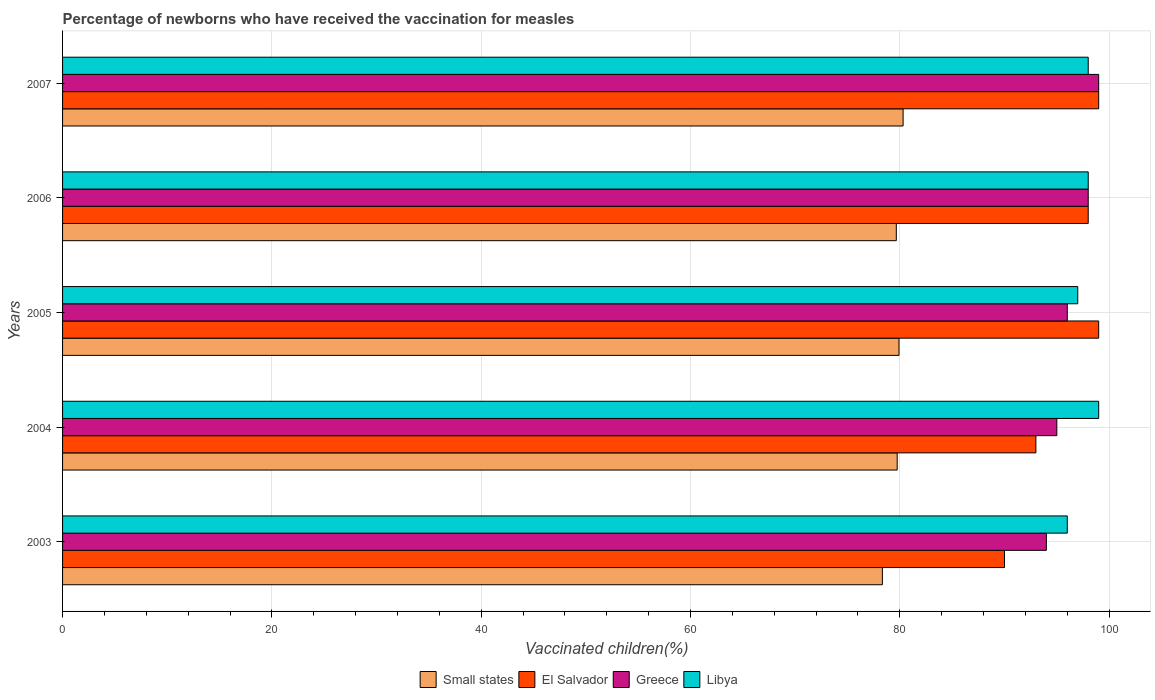Are the number of bars per tick equal to the number of legend labels?
Keep it short and to the point. Yes. How many bars are there on the 4th tick from the top?
Ensure brevity in your answer.  4. Across all years, what is the maximum percentage of vaccinated children in Greece?
Make the answer very short. 99. Across all years, what is the minimum percentage of vaccinated children in El Salvador?
Your answer should be compact. 90. In which year was the percentage of vaccinated children in Greece maximum?
Provide a short and direct response. 2007. In which year was the percentage of vaccinated children in Libya minimum?
Offer a very short reply. 2003. What is the total percentage of vaccinated children in El Salvador in the graph?
Your response must be concise. 479. What is the difference between the percentage of vaccinated children in Greece in 2003 and that in 2007?
Provide a succinct answer. -5. What is the average percentage of vaccinated children in El Salvador per year?
Your answer should be very brief. 95.8. In the year 2007, what is the difference between the percentage of vaccinated children in Libya and percentage of vaccinated children in Small states?
Offer a terse response. 17.69. In how many years, is the percentage of vaccinated children in Libya greater than 12 %?
Ensure brevity in your answer.  5. What is the ratio of the percentage of vaccinated children in El Salvador in 2004 to that in 2006?
Provide a succinct answer. 0.95. Is the percentage of vaccinated children in Libya in 2004 less than that in 2007?
Keep it short and to the point. No. What is the difference between the highest and the second highest percentage of vaccinated children in Small states?
Provide a short and direct response. 0.39. What is the difference between the highest and the lowest percentage of vaccinated children in Libya?
Offer a very short reply. 3. In how many years, is the percentage of vaccinated children in Libya greater than the average percentage of vaccinated children in Libya taken over all years?
Give a very brief answer. 3. Is it the case that in every year, the sum of the percentage of vaccinated children in Greece and percentage of vaccinated children in Libya is greater than the sum of percentage of vaccinated children in Small states and percentage of vaccinated children in El Salvador?
Give a very brief answer. Yes. What does the 1st bar from the top in 2004 represents?
Your answer should be compact. Libya. Are all the bars in the graph horizontal?
Your response must be concise. Yes. What is the difference between two consecutive major ticks on the X-axis?
Offer a very short reply. 20. Does the graph contain any zero values?
Keep it short and to the point. No. Where does the legend appear in the graph?
Make the answer very short. Bottom center. How many legend labels are there?
Give a very brief answer. 4. How are the legend labels stacked?
Provide a succinct answer. Horizontal. What is the title of the graph?
Keep it short and to the point. Percentage of newborns who have received the vaccination for measles. What is the label or title of the X-axis?
Provide a succinct answer. Vaccinated children(%). What is the Vaccinated children(%) in Small states in 2003?
Provide a succinct answer. 78.33. What is the Vaccinated children(%) of Greece in 2003?
Ensure brevity in your answer.  94. What is the Vaccinated children(%) in Libya in 2003?
Your response must be concise. 96. What is the Vaccinated children(%) in Small states in 2004?
Provide a short and direct response. 79.75. What is the Vaccinated children(%) in El Salvador in 2004?
Provide a succinct answer. 93. What is the Vaccinated children(%) of Greece in 2004?
Give a very brief answer. 95. What is the Vaccinated children(%) in Small states in 2005?
Keep it short and to the point. 79.92. What is the Vaccinated children(%) of El Salvador in 2005?
Give a very brief answer. 99. What is the Vaccinated children(%) in Greece in 2005?
Ensure brevity in your answer.  96. What is the Vaccinated children(%) of Libya in 2005?
Offer a very short reply. 97. What is the Vaccinated children(%) in Small states in 2006?
Give a very brief answer. 79.66. What is the Vaccinated children(%) of El Salvador in 2006?
Your answer should be very brief. 98. What is the Vaccinated children(%) of Greece in 2006?
Offer a very short reply. 98. What is the Vaccinated children(%) of Small states in 2007?
Make the answer very short. 80.31. What is the Vaccinated children(%) in El Salvador in 2007?
Keep it short and to the point. 99. What is the Vaccinated children(%) of Greece in 2007?
Provide a short and direct response. 99. What is the Vaccinated children(%) in Libya in 2007?
Give a very brief answer. 98. Across all years, what is the maximum Vaccinated children(%) of Small states?
Give a very brief answer. 80.31. Across all years, what is the maximum Vaccinated children(%) of Greece?
Give a very brief answer. 99. Across all years, what is the minimum Vaccinated children(%) in Small states?
Provide a short and direct response. 78.33. Across all years, what is the minimum Vaccinated children(%) in El Salvador?
Your response must be concise. 90. Across all years, what is the minimum Vaccinated children(%) in Greece?
Provide a succinct answer. 94. Across all years, what is the minimum Vaccinated children(%) in Libya?
Provide a short and direct response. 96. What is the total Vaccinated children(%) in Small states in the graph?
Offer a very short reply. 397.98. What is the total Vaccinated children(%) in El Salvador in the graph?
Ensure brevity in your answer.  479. What is the total Vaccinated children(%) of Greece in the graph?
Give a very brief answer. 482. What is the total Vaccinated children(%) of Libya in the graph?
Make the answer very short. 488. What is the difference between the Vaccinated children(%) in Small states in 2003 and that in 2004?
Offer a terse response. -1.41. What is the difference between the Vaccinated children(%) of Libya in 2003 and that in 2004?
Ensure brevity in your answer.  -3. What is the difference between the Vaccinated children(%) in Small states in 2003 and that in 2005?
Offer a terse response. -1.59. What is the difference between the Vaccinated children(%) in El Salvador in 2003 and that in 2005?
Ensure brevity in your answer.  -9. What is the difference between the Vaccinated children(%) in Small states in 2003 and that in 2006?
Your answer should be compact. -1.33. What is the difference between the Vaccinated children(%) in Greece in 2003 and that in 2006?
Ensure brevity in your answer.  -4. What is the difference between the Vaccinated children(%) in Libya in 2003 and that in 2006?
Make the answer very short. -2. What is the difference between the Vaccinated children(%) in Small states in 2003 and that in 2007?
Offer a very short reply. -1.98. What is the difference between the Vaccinated children(%) of El Salvador in 2003 and that in 2007?
Your response must be concise. -9. What is the difference between the Vaccinated children(%) of Greece in 2003 and that in 2007?
Your answer should be very brief. -5. What is the difference between the Vaccinated children(%) of Libya in 2003 and that in 2007?
Ensure brevity in your answer.  -2. What is the difference between the Vaccinated children(%) in Small states in 2004 and that in 2005?
Make the answer very short. -0.17. What is the difference between the Vaccinated children(%) in Libya in 2004 and that in 2005?
Make the answer very short. 2. What is the difference between the Vaccinated children(%) in Small states in 2004 and that in 2006?
Offer a very short reply. 0.08. What is the difference between the Vaccinated children(%) in Libya in 2004 and that in 2006?
Make the answer very short. 1. What is the difference between the Vaccinated children(%) of Small states in 2004 and that in 2007?
Keep it short and to the point. -0.56. What is the difference between the Vaccinated children(%) of El Salvador in 2004 and that in 2007?
Offer a terse response. -6. What is the difference between the Vaccinated children(%) in Libya in 2004 and that in 2007?
Provide a short and direct response. 1. What is the difference between the Vaccinated children(%) in Small states in 2005 and that in 2006?
Offer a very short reply. 0.26. What is the difference between the Vaccinated children(%) in El Salvador in 2005 and that in 2006?
Give a very brief answer. 1. What is the difference between the Vaccinated children(%) of Greece in 2005 and that in 2006?
Offer a terse response. -2. What is the difference between the Vaccinated children(%) of Libya in 2005 and that in 2006?
Provide a succinct answer. -1. What is the difference between the Vaccinated children(%) in Small states in 2005 and that in 2007?
Keep it short and to the point. -0.39. What is the difference between the Vaccinated children(%) of Greece in 2005 and that in 2007?
Your response must be concise. -3. What is the difference between the Vaccinated children(%) in Libya in 2005 and that in 2007?
Provide a succinct answer. -1. What is the difference between the Vaccinated children(%) in Small states in 2006 and that in 2007?
Make the answer very short. -0.65. What is the difference between the Vaccinated children(%) of El Salvador in 2006 and that in 2007?
Make the answer very short. -1. What is the difference between the Vaccinated children(%) of Greece in 2006 and that in 2007?
Offer a very short reply. -1. What is the difference between the Vaccinated children(%) of Small states in 2003 and the Vaccinated children(%) of El Salvador in 2004?
Your response must be concise. -14.67. What is the difference between the Vaccinated children(%) in Small states in 2003 and the Vaccinated children(%) in Greece in 2004?
Offer a very short reply. -16.67. What is the difference between the Vaccinated children(%) in Small states in 2003 and the Vaccinated children(%) in Libya in 2004?
Offer a very short reply. -20.67. What is the difference between the Vaccinated children(%) in El Salvador in 2003 and the Vaccinated children(%) in Greece in 2004?
Give a very brief answer. -5. What is the difference between the Vaccinated children(%) in Greece in 2003 and the Vaccinated children(%) in Libya in 2004?
Offer a very short reply. -5. What is the difference between the Vaccinated children(%) of Small states in 2003 and the Vaccinated children(%) of El Salvador in 2005?
Provide a short and direct response. -20.67. What is the difference between the Vaccinated children(%) of Small states in 2003 and the Vaccinated children(%) of Greece in 2005?
Give a very brief answer. -17.67. What is the difference between the Vaccinated children(%) in Small states in 2003 and the Vaccinated children(%) in Libya in 2005?
Give a very brief answer. -18.67. What is the difference between the Vaccinated children(%) in Small states in 2003 and the Vaccinated children(%) in El Salvador in 2006?
Offer a terse response. -19.67. What is the difference between the Vaccinated children(%) in Small states in 2003 and the Vaccinated children(%) in Greece in 2006?
Your answer should be very brief. -19.67. What is the difference between the Vaccinated children(%) in Small states in 2003 and the Vaccinated children(%) in Libya in 2006?
Your answer should be compact. -19.67. What is the difference between the Vaccinated children(%) in El Salvador in 2003 and the Vaccinated children(%) in Greece in 2006?
Your answer should be very brief. -8. What is the difference between the Vaccinated children(%) in El Salvador in 2003 and the Vaccinated children(%) in Libya in 2006?
Your response must be concise. -8. What is the difference between the Vaccinated children(%) of Greece in 2003 and the Vaccinated children(%) of Libya in 2006?
Offer a terse response. -4. What is the difference between the Vaccinated children(%) in Small states in 2003 and the Vaccinated children(%) in El Salvador in 2007?
Your answer should be very brief. -20.67. What is the difference between the Vaccinated children(%) in Small states in 2003 and the Vaccinated children(%) in Greece in 2007?
Give a very brief answer. -20.67. What is the difference between the Vaccinated children(%) of Small states in 2003 and the Vaccinated children(%) of Libya in 2007?
Your response must be concise. -19.67. What is the difference between the Vaccinated children(%) in El Salvador in 2003 and the Vaccinated children(%) in Libya in 2007?
Keep it short and to the point. -8. What is the difference between the Vaccinated children(%) in Small states in 2004 and the Vaccinated children(%) in El Salvador in 2005?
Keep it short and to the point. -19.25. What is the difference between the Vaccinated children(%) of Small states in 2004 and the Vaccinated children(%) of Greece in 2005?
Offer a very short reply. -16.25. What is the difference between the Vaccinated children(%) of Small states in 2004 and the Vaccinated children(%) of Libya in 2005?
Offer a terse response. -17.25. What is the difference between the Vaccinated children(%) of El Salvador in 2004 and the Vaccinated children(%) of Greece in 2005?
Provide a succinct answer. -3. What is the difference between the Vaccinated children(%) in El Salvador in 2004 and the Vaccinated children(%) in Libya in 2005?
Provide a short and direct response. -4. What is the difference between the Vaccinated children(%) in Greece in 2004 and the Vaccinated children(%) in Libya in 2005?
Ensure brevity in your answer.  -2. What is the difference between the Vaccinated children(%) in Small states in 2004 and the Vaccinated children(%) in El Salvador in 2006?
Ensure brevity in your answer.  -18.25. What is the difference between the Vaccinated children(%) of Small states in 2004 and the Vaccinated children(%) of Greece in 2006?
Offer a terse response. -18.25. What is the difference between the Vaccinated children(%) of Small states in 2004 and the Vaccinated children(%) of Libya in 2006?
Your answer should be compact. -18.25. What is the difference between the Vaccinated children(%) of El Salvador in 2004 and the Vaccinated children(%) of Greece in 2006?
Provide a succinct answer. -5. What is the difference between the Vaccinated children(%) in Small states in 2004 and the Vaccinated children(%) in El Salvador in 2007?
Give a very brief answer. -19.25. What is the difference between the Vaccinated children(%) of Small states in 2004 and the Vaccinated children(%) of Greece in 2007?
Give a very brief answer. -19.25. What is the difference between the Vaccinated children(%) of Small states in 2004 and the Vaccinated children(%) of Libya in 2007?
Offer a terse response. -18.25. What is the difference between the Vaccinated children(%) in El Salvador in 2004 and the Vaccinated children(%) in Greece in 2007?
Ensure brevity in your answer.  -6. What is the difference between the Vaccinated children(%) in El Salvador in 2004 and the Vaccinated children(%) in Libya in 2007?
Your answer should be compact. -5. What is the difference between the Vaccinated children(%) of Small states in 2005 and the Vaccinated children(%) of El Salvador in 2006?
Make the answer very short. -18.08. What is the difference between the Vaccinated children(%) in Small states in 2005 and the Vaccinated children(%) in Greece in 2006?
Your answer should be compact. -18.08. What is the difference between the Vaccinated children(%) in Small states in 2005 and the Vaccinated children(%) in Libya in 2006?
Offer a very short reply. -18.08. What is the difference between the Vaccinated children(%) in El Salvador in 2005 and the Vaccinated children(%) in Libya in 2006?
Offer a terse response. 1. What is the difference between the Vaccinated children(%) of Small states in 2005 and the Vaccinated children(%) of El Salvador in 2007?
Make the answer very short. -19.08. What is the difference between the Vaccinated children(%) in Small states in 2005 and the Vaccinated children(%) in Greece in 2007?
Your response must be concise. -19.08. What is the difference between the Vaccinated children(%) in Small states in 2005 and the Vaccinated children(%) in Libya in 2007?
Your response must be concise. -18.08. What is the difference between the Vaccinated children(%) in El Salvador in 2005 and the Vaccinated children(%) in Greece in 2007?
Your response must be concise. 0. What is the difference between the Vaccinated children(%) of Small states in 2006 and the Vaccinated children(%) of El Salvador in 2007?
Keep it short and to the point. -19.34. What is the difference between the Vaccinated children(%) in Small states in 2006 and the Vaccinated children(%) in Greece in 2007?
Your answer should be very brief. -19.34. What is the difference between the Vaccinated children(%) in Small states in 2006 and the Vaccinated children(%) in Libya in 2007?
Ensure brevity in your answer.  -18.34. What is the difference between the Vaccinated children(%) in El Salvador in 2006 and the Vaccinated children(%) in Greece in 2007?
Give a very brief answer. -1. What is the difference between the Vaccinated children(%) of Greece in 2006 and the Vaccinated children(%) of Libya in 2007?
Make the answer very short. 0. What is the average Vaccinated children(%) in Small states per year?
Offer a terse response. 79.6. What is the average Vaccinated children(%) of El Salvador per year?
Your answer should be compact. 95.8. What is the average Vaccinated children(%) of Greece per year?
Your response must be concise. 96.4. What is the average Vaccinated children(%) in Libya per year?
Your answer should be compact. 97.6. In the year 2003, what is the difference between the Vaccinated children(%) of Small states and Vaccinated children(%) of El Salvador?
Keep it short and to the point. -11.67. In the year 2003, what is the difference between the Vaccinated children(%) of Small states and Vaccinated children(%) of Greece?
Offer a terse response. -15.67. In the year 2003, what is the difference between the Vaccinated children(%) of Small states and Vaccinated children(%) of Libya?
Provide a short and direct response. -17.67. In the year 2003, what is the difference between the Vaccinated children(%) in El Salvador and Vaccinated children(%) in Greece?
Make the answer very short. -4. In the year 2003, what is the difference between the Vaccinated children(%) of Greece and Vaccinated children(%) of Libya?
Provide a short and direct response. -2. In the year 2004, what is the difference between the Vaccinated children(%) of Small states and Vaccinated children(%) of El Salvador?
Ensure brevity in your answer.  -13.25. In the year 2004, what is the difference between the Vaccinated children(%) in Small states and Vaccinated children(%) in Greece?
Your answer should be compact. -15.25. In the year 2004, what is the difference between the Vaccinated children(%) of Small states and Vaccinated children(%) of Libya?
Your answer should be compact. -19.25. In the year 2004, what is the difference between the Vaccinated children(%) in El Salvador and Vaccinated children(%) in Libya?
Your answer should be compact. -6. In the year 2005, what is the difference between the Vaccinated children(%) in Small states and Vaccinated children(%) in El Salvador?
Keep it short and to the point. -19.08. In the year 2005, what is the difference between the Vaccinated children(%) in Small states and Vaccinated children(%) in Greece?
Ensure brevity in your answer.  -16.08. In the year 2005, what is the difference between the Vaccinated children(%) of Small states and Vaccinated children(%) of Libya?
Provide a short and direct response. -17.08. In the year 2005, what is the difference between the Vaccinated children(%) of El Salvador and Vaccinated children(%) of Greece?
Offer a very short reply. 3. In the year 2005, what is the difference between the Vaccinated children(%) in Greece and Vaccinated children(%) in Libya?
Your response must be concise. -1. In the year 2006, what is the difference between the Vaccinated children(%) of Small states and Vaccinated children(%) of El Salvador?
Give a very brief answer. -18.34. In the year 2006, what is the difference between the Vaccinated children(%) in Small states and Vaccinated children(%) in Greece?
Your answer should be very brief. -18.34. In the year 2006, what is the difference between the Vaccinated children(%) of Small states and Vaccinated children(%) of Libya?
Make the answer very short. -18.34. In the year 2006, what is the difference between the Vaccinated children(%) of El Salvador and Vaccinated children(%) of Libya?
Your answer should be very brief. 0. In the year 2007, what is the difference between the Vaccinated children(%) in Small states and Vaccinated children(%) in El Salvador?
Your answer should be compact. -18.69. In the year 2007, what is the difference between the Vaccinated children(%) in Small states and Vaccinated children(%) in Greece?
Give a very brief answer. -18.69. In the year 2007, what is the difference between the Vaccinated children(%) of Small states and Vaccinated children(%) of Libya?
Provide a short and direct response. -17.69. In the year 2007, what is the difference between the Vaccinated children(%) in El Salvador and Vaccinated children(%) in Libya?
Your answer should be very brief. 1. What is the ratio of the Vaccinated children(%) of Small states in 2003 to that in 2004?
Ensure brevity in your answer.  0.98. What is the ratio of the Vaccinated children(%) of Libya in 2003 to that in 2004?
Your response must be concise. 0.97. What is the ratio of the Vaccinated children(%) of Small states in 2003 to that in 2005?
Make the answer very short. 0.98. What is the ratio of the Vaccinated children(%) of El Salvador in 2003 to that in 2005?
Ensure brevity in your answer.  0.91. What is the ratio of the Vaccinated children(%) of Greece in 2003 to that in 2005?
Offer a very short reply. 0.98. What is the ratio of the Vaccinated children(%) in Small states in 2003 to that in 2006?
Offer a very short reply. 0.98. What is the ratio of the Vaccinated children(%) of El Salvador in 2003 to that in 2006?
Provide a short and direct response. 0.92. What is the ratio of the Vaccinated children(%) in Greece in 2003 to that in 2006?
Offer a terse response. 0.96. What is the ratio of the Vaccinated children(%) of Libya in 2003 to that in 2006?
Give a very brief answer. 0.98. What is the ratio of the Vaccinated children(%) in Small states in 2003 to that in 2007?
Ensure brevity in your answer.  0.98. What is the ratio of the Vaccinated children(%) of El Salvador in 2003 to that in 2007?
Make the answer very short. 0.91. What is the ratio of the Vaccinated children(%) in Greece in 2003 to that in 2007?
Provide a succinct answer. 0.95. What is the ratio of the Vaccinated children(%) of Libya in 2003 to that in 2007?
Ensure brevity in your answer.  0.98. What is the ratio of the Vaccinated children(%) in Small states in 2004 to that in 2005?
Your answer should be compact. 1. What is the ratio of the Vaccinated children(%) in El Salvador in 2004 to that in 2005?
Your response must be concise. 0.94. What is the ratio of the Vaccinated children(%) of Libya in 2004 to that in 2005?
Give a very brief answer. 1.02. What is the ratio of the Vaccinated children(%) of El Salvador in 2004 to that in 2006?
Your answer should be very brief. 0.95. What is the ratio of the Vaccinated children(%) of Greece in 2004 to that in 2006?
Make the answer very short. 0.97. What is the ratio of the Vaccinated children(%) in Libya in 2004 to that in 2006?
Your answer should be very brief. 1.01. What is the ratio of the Vaccinated children(%) in Small states in 2004 to that in 2007?
Your response must be concise. 0.99. What is the ratio of the Vaccinated children(%) in El Salvador in 2004 to that in 2007?
Provide a succinct answer. 0.94. What is the ratio of the Vaccinated children(%) of Greece in 2004 to that in 2007?
Give a very brief answer. 0.96. What is the ratio of the Vaccinated children(%) of Libya in 2004 to that in 2007?
Your response must be concise. 1.01. What is the ratio of the Vaccinated children(%) of Small states in 2005 to that in 2006?
Your answer should be compact. 1. What is the ratio of the Vaccinated children(%) of El Salvador in 2005 to that in 2006?
Offer a terse response. 1.01. What is the ratio of the Vaccinated children(%) of Greece in 2005 to that in 2006?
Your response must be concise. 0.98. What is the ratio of the Vaccinated children(%) of Small states in 2005 to that in 2007?
Provide a short and direct response. 1. What is the ratio of the Vaccinated children(%) in Greece in 2005 to that in 2007?
Your response must be concise. 0.97. What is the ratio of the Vaccinated children(%) of Libya in 2005 to that in 2007?
Make the answer very short. 0.99. What is the ratio of the Vaccinated children(%) in Small states in 2006 to that in 2007?
Offer a terse response. 0.99. What is the ratio of the Vaccinated children(%) of El Salvador in 2006 to that in 2007?
Offer a terse response. 0.99. What is the ratio of the Vaccinated children(%) in Greece in 2006 to that in 2007?
Provide a short and direct response. 0.99. What is the ratio of the Vaccinated children(%) of Libya in 2006 to that in 2007?
Give a very brief answer. 1. What is the difference between the highest and the second highest Vaccinated children(%) in Small states?
Make the answer very short. 0.39. What is the difference between the highest and the second highest Vaccinated children(%) in Greece?
Ensure brevity in your answer.  1. What is the difference between the highest and the lowest Vaccinated children(%) of Small states?
Offer a terse response. 1.98. 